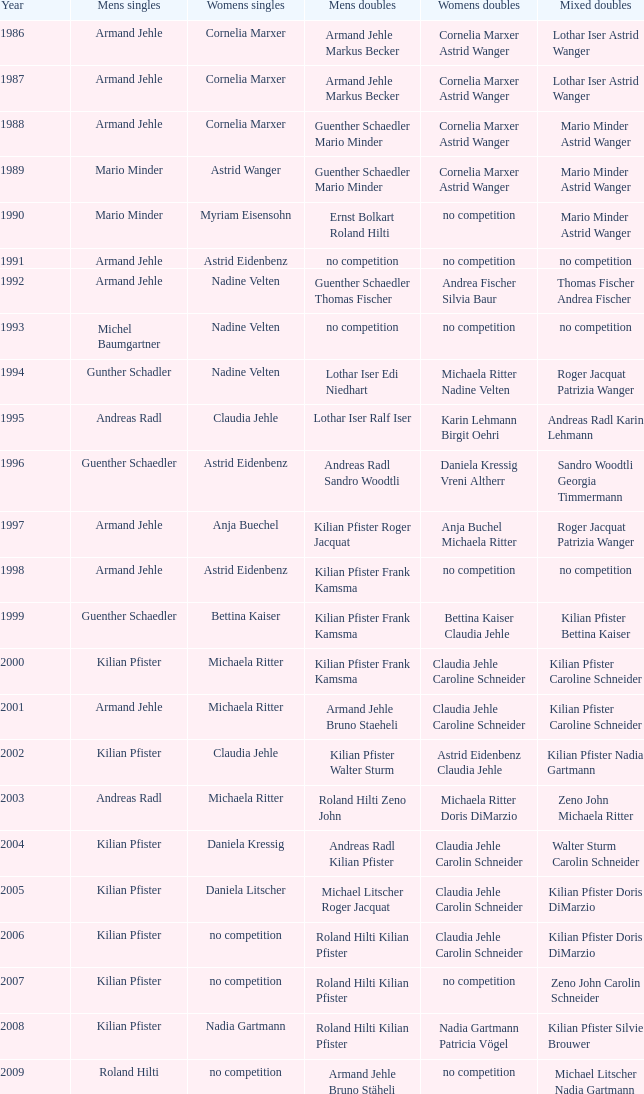In 2006, the women's singles had no contest and the men's doubles featured roland hilti and kilian pfister, who were the women's doubles? Claudia Jehle Carolin Schneider. 